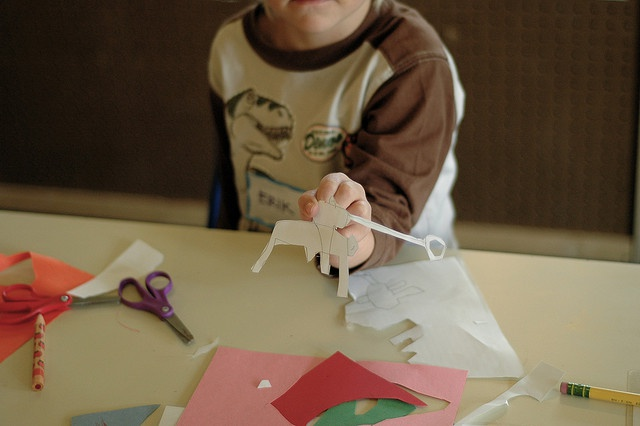Describe the objects in this image and their specific colors. I can see people in black, gray, and maroon tones and scissors in black, maroon, olive, and gray tones in this image. 